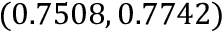<formula> <loc_0><loc_0><loc_500><loc_500>( 0 . 7 5 0 8 , 0 . 7 7 4 2 )</formula> 